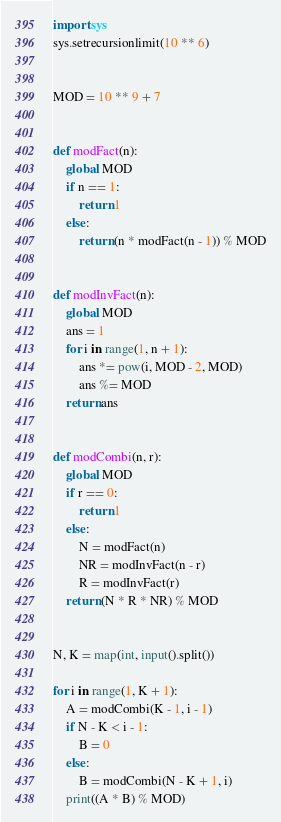Convert code to text. <code><loc_0><loc_0><loc_500><loc_500><_Python_>import sys
sys.setrecursionlimit(10 ** 6)


MOD = 10 ** 9 + 7


def modFact(n):
    global MOD
    if n == 1:
        return 1
    else:
        return (n * modFact(n - 1)) % MOD


def modInvFact(n):
    global MOD
    ans = 1
    for i in range(1, n + 1):
        ans *= pow(i, MOD - 2, MOD)
        ans %= MOD
    return ans


def modCombi(n, r):
    global MOD
    if r == 0:
        return 1
    else:
        N = modFact(n)
        NR = modInvFact(n - r)
        R = modInvFact(r)
    return (N * R * NR) % MOD


N, K = map(int, input().split())

for i in range(1, K + 1):
    A = modCombi(K - 1, i - 1)
    if N - K < i - 1:
        B = 0
    else:
        B = modCombi(N - K + 1, i)
    print((A * B) % MOD)
</code> 